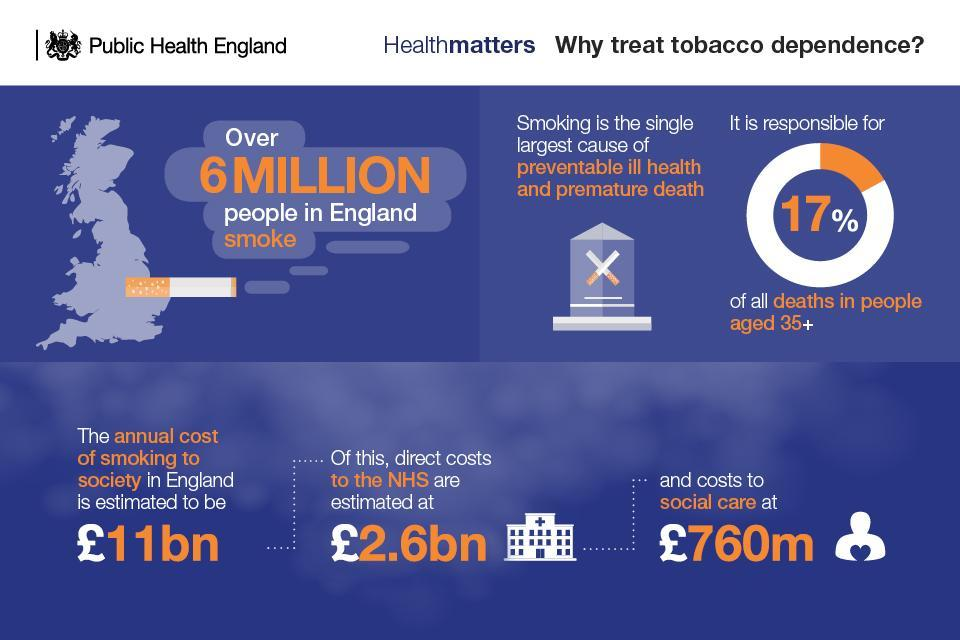What is costs incurred directly to the NHS due to smoking, 11bn pounds, 760m pounds, or 2.6bn pounds?
Answer the question with a short phrase. 2.6bn pounds 